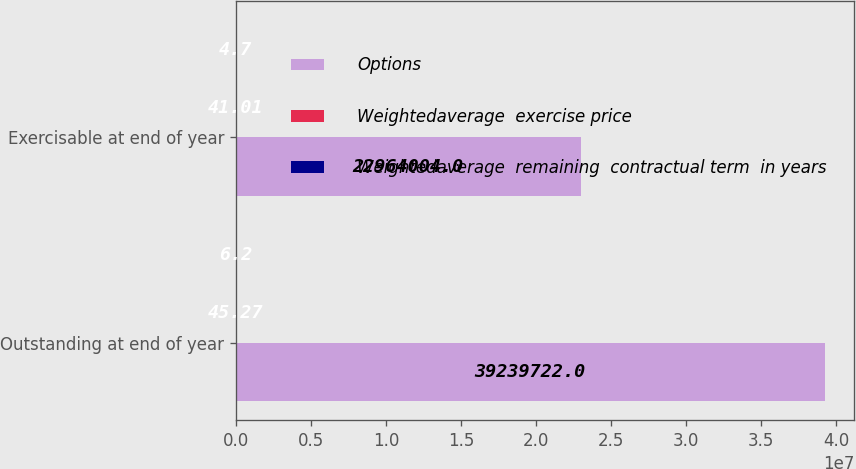<chart> <loc_0><loc_0><loc_500><loc_500><stacked_bar_chart><ecel><fcel>Outstanding at end of year<fcel>Exercisable at end of year<nl><fcel>Options<fcel>3.92397e+07<fcel>2.2964e+07<nl><fcel>Weightedaverage  exercise price<fcel>45.27<fcel>41.01<nl><fcel>Weightedaverage  remaining  contractual term  in years<fcel>6.2<fcel>4.7<nl></chart> 